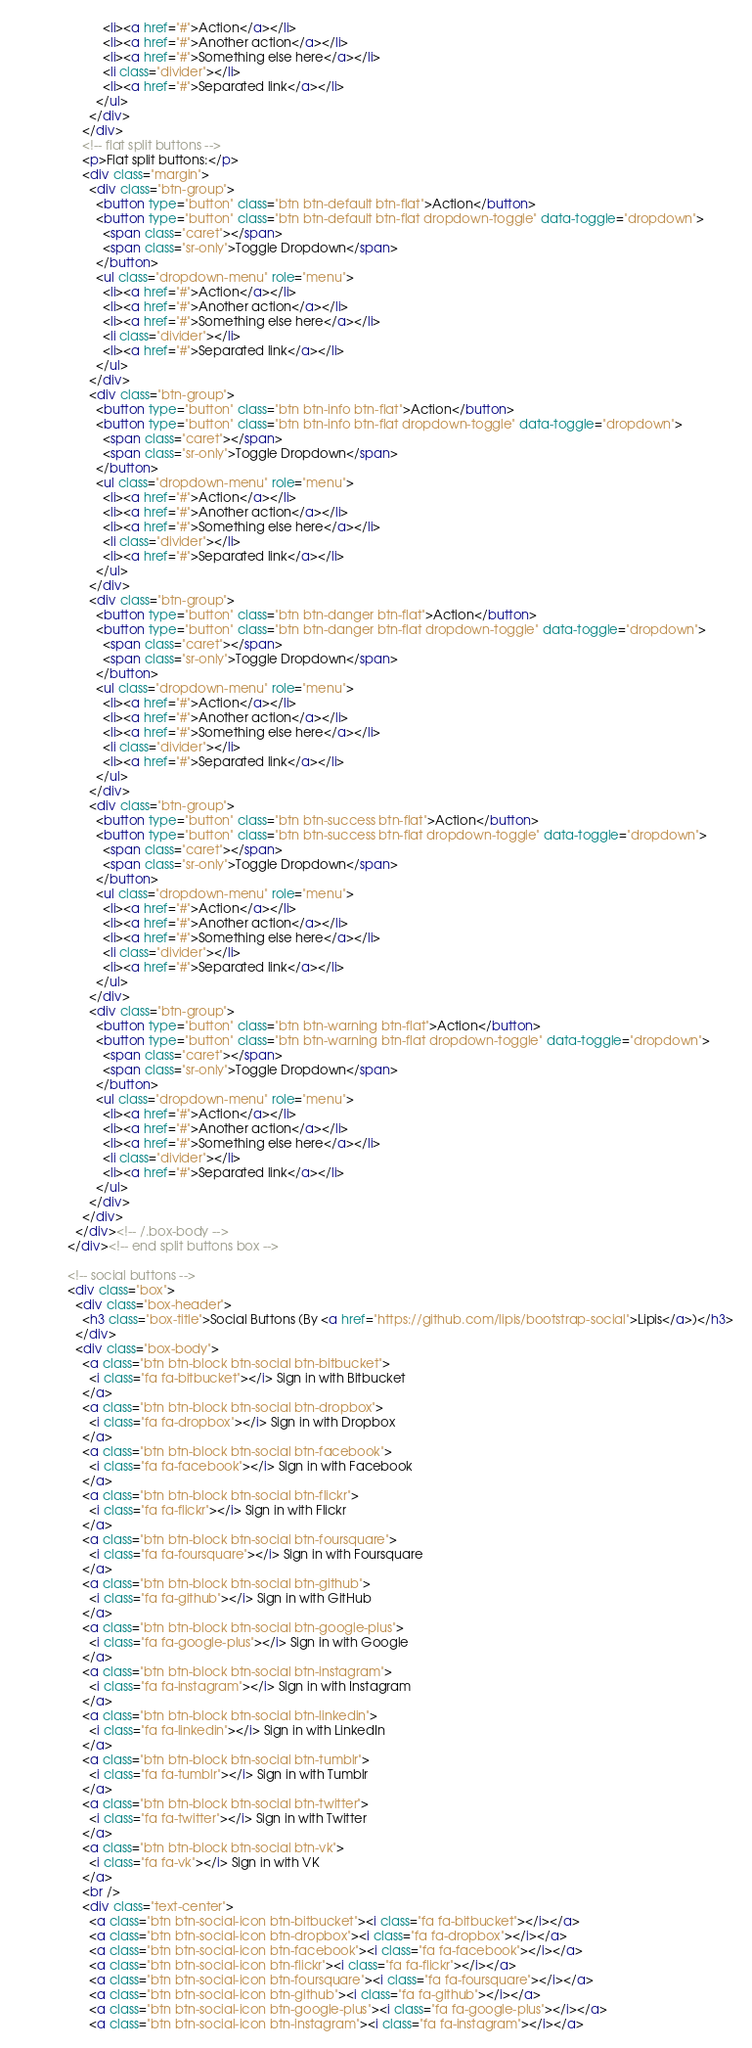<code> <loc_0><loc_0><loc_500><loc_500><_HTML_>                        <li><a href="#">Action</a></li>
                        <li><a href="#">Another action</a></li>
                        <li><a href="#">Something else here</a></li>
                        <li class="divider"></li>
                        <li><a href="#">Separated link</a></li>
                      </ul>
                    </div>
                  </div>
                  <!-- flat split buttons -->
                  <p>Flat split buttons:</p>
                  <div class="margin">
                    <div class="btn-group">
                      <button type="button" class="btn btn-default btn-flat">Action</button>
                      <button type="button" class="btn btn-default btn-flat dropdown-toggle" data-toggle="dropdown">
                        <span class="caret"></span>
                        <span class="sr-only">Toggle Dropdown</span>
                      </button>
                      <ul class="dropdown-menu" role="menu">
                        <li><a href="#">Action</a></li>
                        <li><a href="#">Another action</a></li>
                        <li><a href="#">Something else here</a></li>
                        <li class="divider"></li>
                        <li><a href="#">Separated link</a></li>
                      </ul>
                    </div>
                    <div class="btn-group">
                      <button type="button" class="btn btn-info btn-flat">Action</button>
                      <button type="button" class="btn btn-info btn-flat dropdown-toggle" data-toggle="dropdown">
                        <span class="caret"></span>
                        <span class="sr-only">Toggle Dropdown</span>
                      </button>
                      <ul class="dropdown-menu" role="menu">
                        <li><a href="#">Action</a></li>
                        <li><a href="#">Another action</a></li>
                        <li><a href="#">Something else here</a></li>
                        <li class="divider"></li>
                        <li><a href="#">Separated link</a></li>
                      </ul>
                    </div>
                    <div class="btn-group">
                      <button type="button" class="btn btn-danger btn-flat">Action</button>
                      <button type="button" class="btn btn-danger btn-flat dropdown-toggle" data-toggle="dropdown">
                        <span class="caret"></span>
                        <span class="sr-only">Toggle Dropdown</span>
                      </button>
                      <ul class="dropdown-menu" role="menu">
                        <li><a href="#">Action</a></li>
                        <li><a href="#">Another action</a></li>
                        <li><a href="#">Something else here</a></li>
                        <li class="divider"></li>
                        <li><a href="#">Separated link</a></li>
                      </ul>
                    </div>
                    <div class="btn-group">
                      <button type="button" class="btn btn-success btn-flat">Action</button>
                      <button type="button" class="btn btn-success btn-flat dropdown-toggle" data-toggle="dropdown">
                        <span class="caret"></span>
                        <span class="sr-only">Toggle Dropdown</span>
                      </button>
                      <ul class="dropdown-menu" role="menu">
                        <li><a href="#">Action</a></li>
                        <li><a href="#">Another action</a></li>
                        <li><a href="#">Something else here</a></li>
                        <li class="divider"></li>
                        <li><a href="#">Separated link</a></li>
                      </ul>
                    </div>
                    <div class="btn-group">
                      <button type="button" class="btn btn-warning btn-flat">Action</button>
                      <button type="button" class="btn btn-warning btn-flat dropdown-toggle" data-toggle="dropdown">
                        <span class="caret"></span>
                        <span class="sr-only">Toggle Dropdown</span>
                      </button>
                      <ul class="dropdown-menu" role="menu">
                        <li><a href="#">Action</a></li>
                        <li><a href="#">Another action</a></li>
                        <li><a href="#">Something else here</a></li>
                        <li class="divider"></li>
                        <li><a href="#">Separated link</a></li>
                      </ul>
                    </div>
                  </div>
                </div><!-- /.box-body -->
              </div><!-- end split buttons box -->

              <!-- social buttons -->
              <div class="box">
                <div class="box-header">
                  <h3 class="box-title">Social Buttons (By <a href="https://github.com/lipis/bootstrap-social">Lipis</a>)</h3>
                </div>
                <div class="box-body">
                  <a class="btn btn-block btn-social btn-bitbucket">
                    <i class="fa fa-bitbucket"></i> Sign in with Bitbucket
                  </a>
                  <a class="btn btn-block btn-social btn-dropbox">
                    <i class="fa fa-dropbox"></i> Sign in with Dropbox
                  </a>
                  <a class="btn btn-block btn-social btn-facebook">
                    <i class="fa fa-facebook"></i> Sign in with Facebook
                  </a>
                  <a class="btn btn-block btn-social btn-flickr">
                    <i class="fa fa-flickr"></i> Sign in with Flickr
                  </a>
                  <a class="btn btn-block btn-social btn-foursquare">
                    <i class="fa fa-foursquare"></i> Sign in with Foursquare
                  </a>
                  <a class="btn btn-block btn-social btn-github">
                    <i class="fa fa-github"></i> Sign in with GitHub
                  </a>
                  <a class="btn btn-block btn-social btn-google-plus">
                    <i class="fa fa-google-plus"></i> Sign in with Google
                  </a>
                  <a class="btn btn-block btn-social btn-instagram">
                    <i class="fa fa-instagram"></i> Sign in with Instagram
                  </a>
                  <a class="btn btn-block btn-social btn-linkedin">
                    <i class="fa fa-linkedin"></i> Sign in with LinkedIn
                  </a>
                  <a class="btn btn-block btn-social btn-tumblr">
                    <i class="fa fa-tumblr"></i> Sign in with Tumblr
                  </a>
                  <a class="btn btn-block btn-social btn-twitter">
                    <i class="fa fa-twitter"></i> Sign in with Twitter
                  </a>
                  <a class="btn btn-block btn-social btn-vk">
                    <i class="fa fa-vk"></i> Sign in with VK
                  </a>
                  <br />
                  <div class="text-center">
                    <a class="btn btn-social-icon btn-bitbucket"><i class="fa fa-bitbucket"></i></a>
                    <a class="btn btn-social-icon btn-dropbox"><i class="fa fa-dropbox"></i></a>
                    <a class="btn btn-social-icon btn-facebook"><i class="fa fa-facebook"></i></a>
                    <a class="btn btn-social-icon btn-flickr"><i class="fa fa-flickr"></i></a>
                    <a class="btn btn-social-icon btn-foursquare"><i class="fa fa-foursquare"></i></a>
                    <a class="btn btn-social-icon btn-github"><i class="fa fa-github"></i></a>
                    <a class="btn btn-social-icon btn-google-plus"><i class="fa fa-google-plus"></i></a>
                    <a class="btn btn-social-icon btn-instagram"><i class="fa fa-instagram"></i></a></code> 